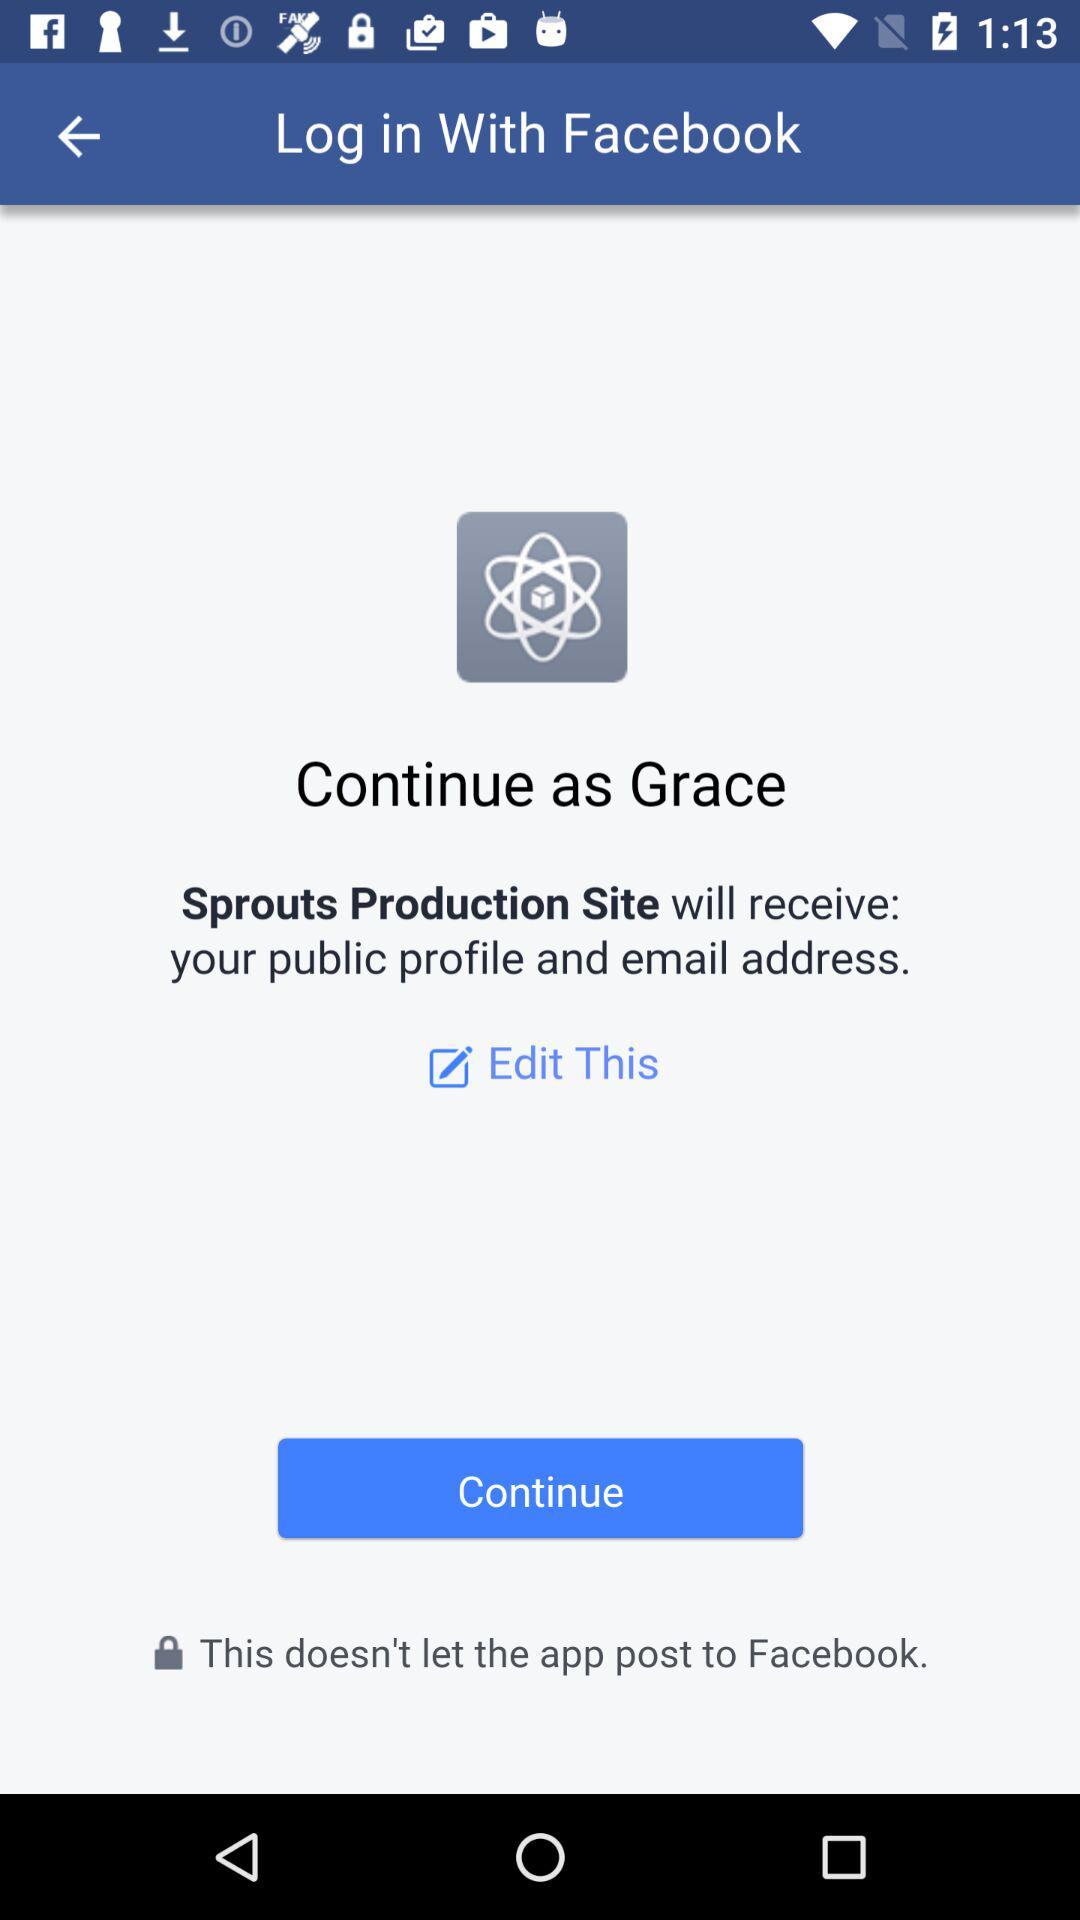Through which application can the user log in? The user can log in through "Facebook". 